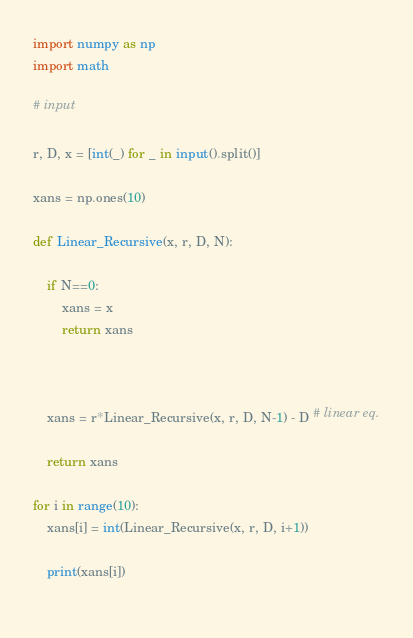Convert code to text. <code><loc_0><loc_0><loc_500><loc_500><_Python_>import numpy as np
import math

# input

r, D, x = [int(_) for _ in input().split()]

xans = np.ones(10)

def Linear_Recursive(x, r, D, N):
    
    if N==0:
        xans = x
        return xans
    
        
    
    xans = r*Linear_Recursive(x, r, D, N-1) - D # linear eq.
    
    return xans
  
for i in range(10):
    xans[i] = int(Linear_Recursive(x, r, D, i+1))
    
    print(xans[i])
    
</code> 